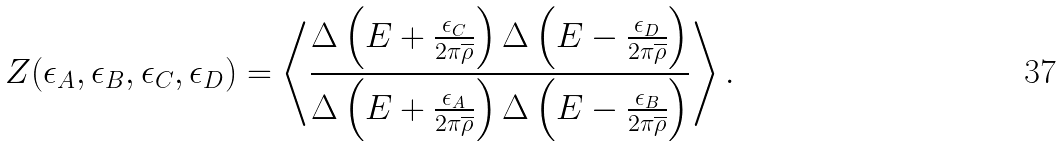<formula> <loc_0><loc_0><loc_500><loc_500>Z ( \epsilon _ { A } , \epsilon _ { B } , \epsilon _ { C } , \epsilon _ { D } ) = \left \langle \frac { \Delta \left ( E + \frac { \epsilon _ { C } } { 2 \pi \overline { \rho } } \right ) \Delta \left ( E - \frac { \epsilon _ { D } } { 2 \pi \overline { \rho } } \right ) } { \Delta \left ( E + \frac { \epsilon _ { A } } { 2 \pi \overline { \rho } } \right ) \Delta \left ( E - \frac { \epsilon _ { B } } { 2 \pi \overline { \rho } } \right ) } \right \rangle .</formula> 